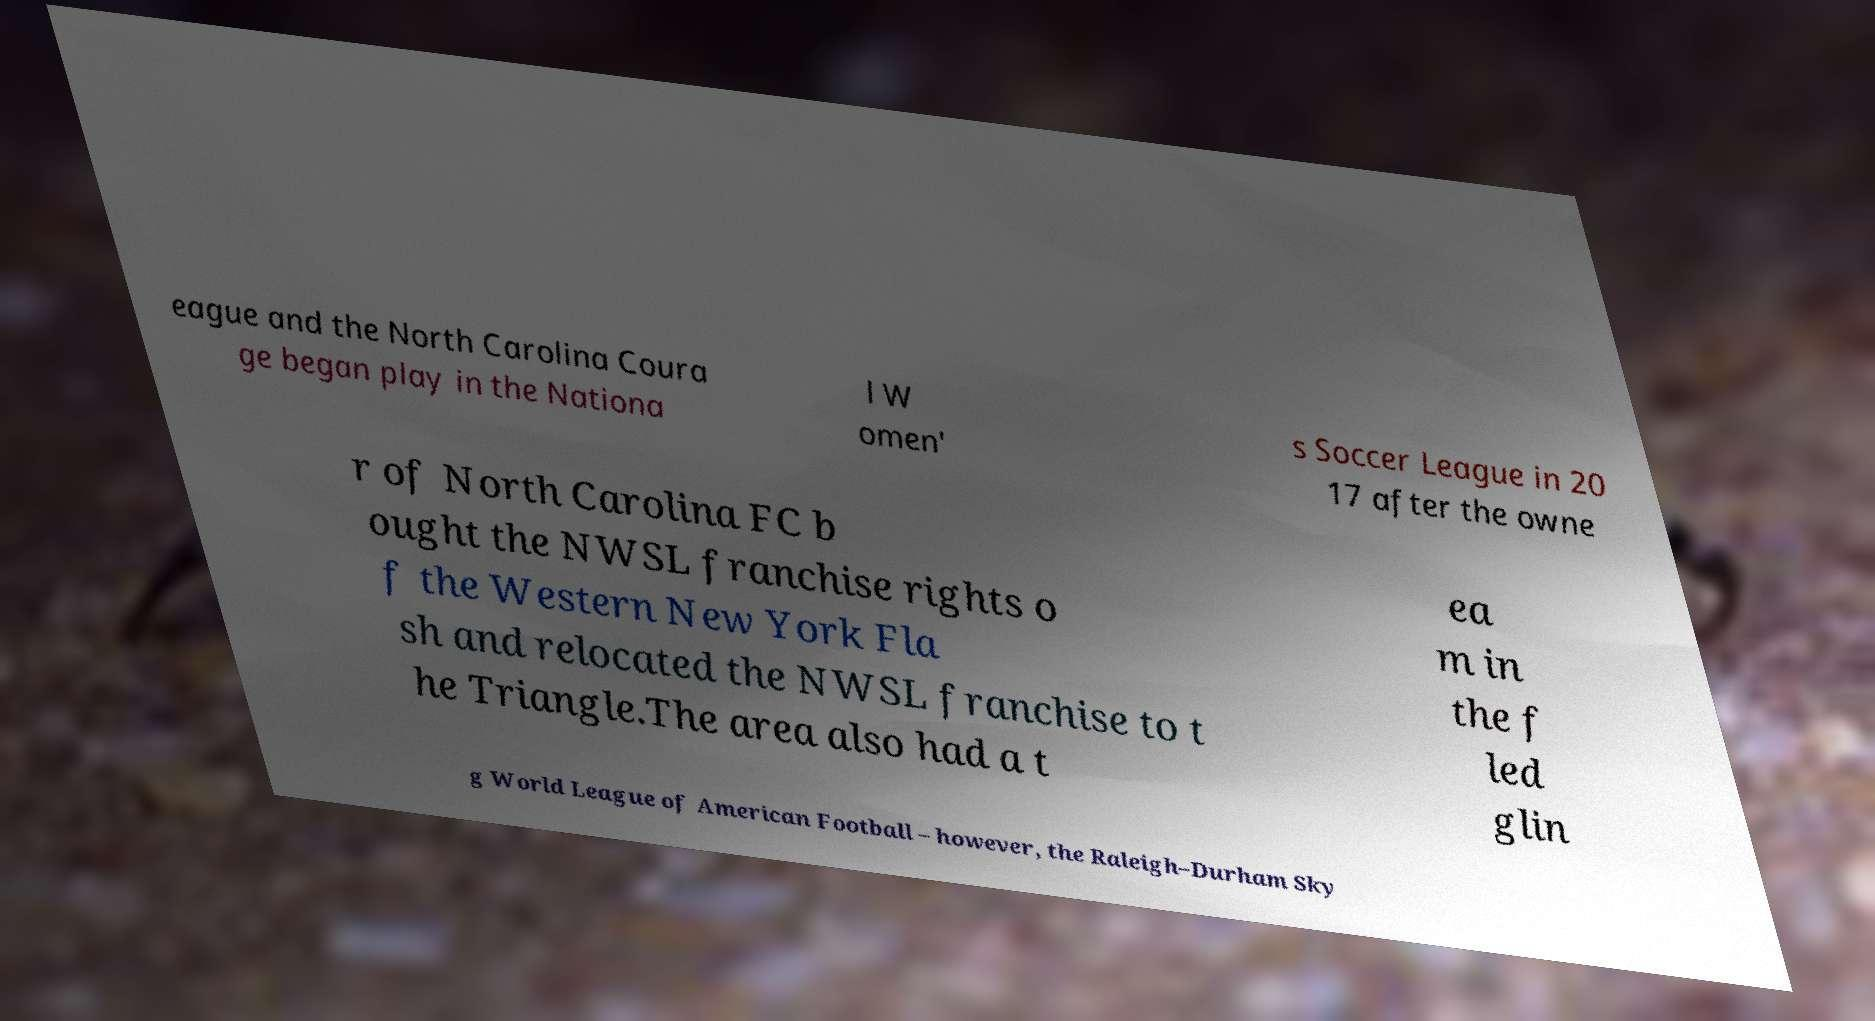I need the written content from this picture converted into text. Can you do that? eague and the North Carolina Coura ge began play in the Nationa l W omen' s Soccer League in 20 17 after the owne r of North Carolina FC b ought the NWSL franchise rights o f the Western New York Fla sh and relocated the NWSL franchise to t he Triangle.The area also had a t ea m in the f led glin g World League of American Football – however, the Raleigh–Durham Sky 